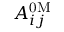<formula> <loc_0><loc_0><loc_500><loc_500>A _ { i j } ^ { 0 M }</formula> 